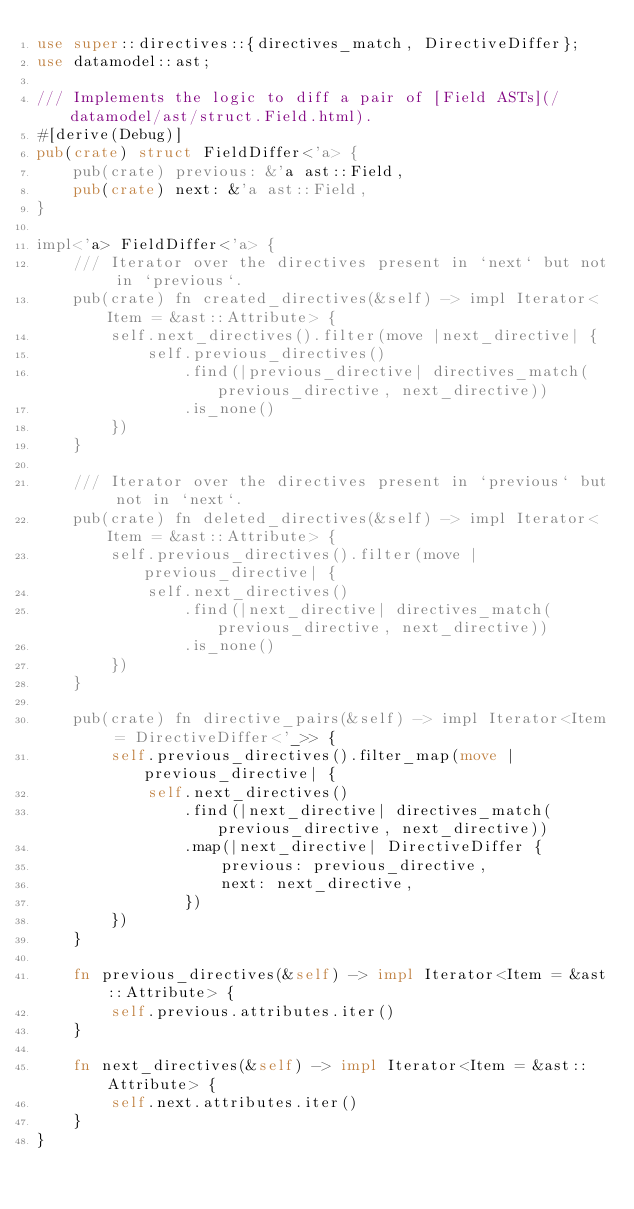Convert code to text. <code><loc_0><loc_0><loc_500><loc_500><_Rust_>use super::directives::{directives_match, DirectiveDiffer};
use datamodel::ast;

/// Implements the logic to diff a pair of [Field ASTs](/datamodel/ast/struct.Field.html).
#[derive(Debug)]
pub(crate) struct FieldDiffer<'a> {
    pub(crate) previous: &'a ast::Field,
    pub(crate) next: &'a ast::Field,
}

impl<'a> FieldDiffer<'a> {
    /// Iterator over the directives present in `next` but not in `previous`.
    pub(crate) fn created_directives(&self) -> impl Iterator<Item = &ast::Attribute> {
        self.next_directives().filter(move |next_directive| {
            self.previous_directives()
                .find(|previous_directive| directives_match(previous_directive, next_directive))
                .is_none()
        })
    }

    /// Iterator over the directives present in `previous` but not in `next`.
    pub(crate) fn deleted_directives(&self) -> impl Iterator<Item = &ast::Attribute> {
        self.previous_directives().filter(move |previous_directive| {
            self.next_directives()
                .find(|next_directive| directives_match(previous_directive, next_directive))
                .is_none()
        })
    }

    pub(crate) fn directive_pairs(&self) -> impl Iterator<Item = DirectiveDiffer<'_>> {
        self.previous_directives().filter_map(move |previous_directive| {
            self.next_directives()
                .find(|next_directive| directives_match(previous_directive, next_directive))
                .map(|next_directive| DirectiveDiffer {
                    previous: previous_directive,
                    next: next_directive,
                })
        })
    }

    fn previous_directives(&self) -> impl Iterator<Item = &ast::Attribute> {
        self.previous.attributes.iter()
    }

    fn next_directives(&self) -> impl Iterator<Item = &ast::Attribute> {
        self.next.attributes.iter()
    }
}
</code> 